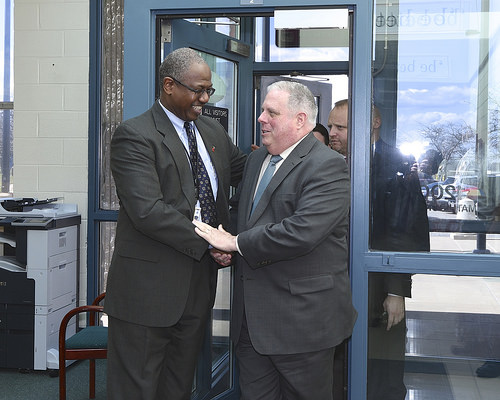<image>
Is there a person behind the person? No. The person is not behind the person. From this viewpoint, the person appears to be positioned elsewhere in the scene. 